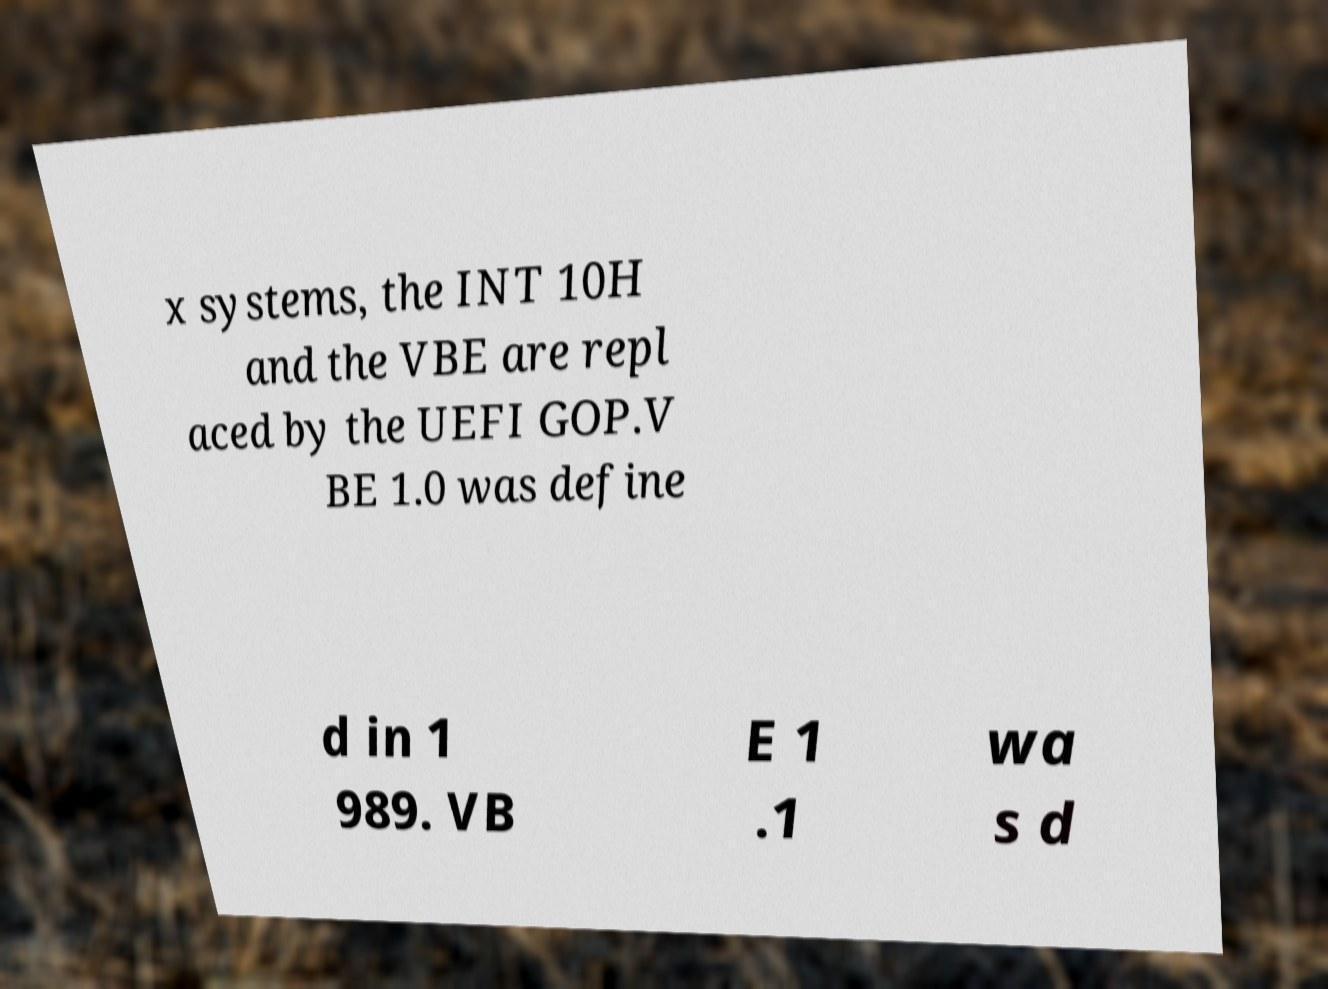Can you read and provide the text displayed in the image?This photo seems to have some interesting text. Can you extract and type it out for me? x systems, the INT 10H and the VBE are repl aced by the UEFI GOP.V BE 1.0 was define d in 1 989. VB E 1 .1 wa s d 